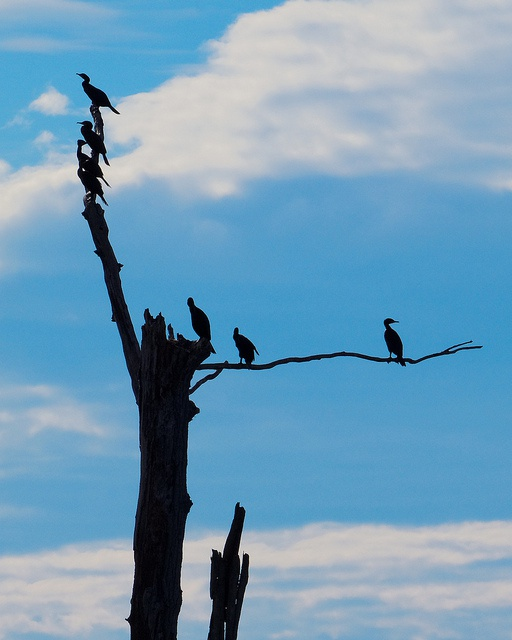Describe the objects in this image and their specific colors. I can see bird in lightgray, black, lightblue, and teal tones, bird in lightgray, black, lightblue, navy, and blue tones, bird in lightgray, black, gray, navy, and blue tones, bird in lightgray, black, lightblue, and navy tones, and bird in lightgray, black, gray, navy, and darkgray tones in this image. 